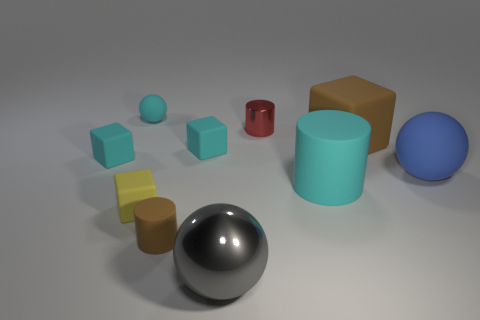There is a big thing that is in front of the big cyan matte cylinder; how many shiny things are behind it? Behind the large cyan matte cylinder, there are three items: a red metallic cylinder, a yellow matte cube, and a blue shiny sphere. If we're referring specifically to shiny objects, then the total count would be one. 